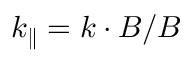Convert formula to latex. <formula><loc_0><loc_0><loc_500><loc_500>k _ { \| } = k \cdot B / B</formula> 